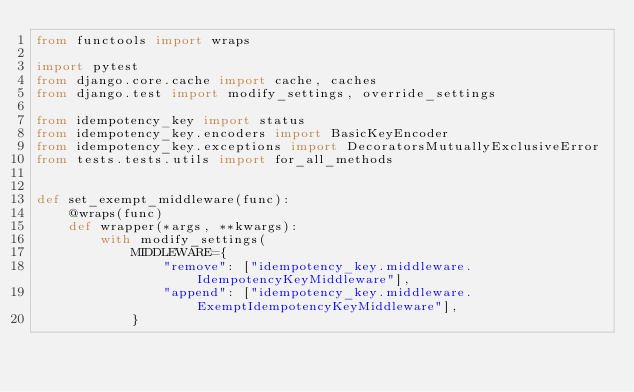Convert code to text. <code><loc_0><loc_0><loc_500><loc_500><_Python_>from functools import wraps

import pytest
from django.core.cache import cache, caches
from django.test import modify_settings, override_settings

from idempotency_key import status
from idempotency_key.encoders import BasicKeyEncoder
from idempotency_key.exceptions import DecoratorsMutuallyExclusiveError
from tests.tests.utils import for_all_methods


def set_exempt_middleware(func):
    @wraps(func)
    def wrapper(*args, **kwargs):
        with modify_settings(
            MIDDLEWARE={
                "remove": ["idempotency_key.middleware.IdempotencyKeyMiddleware"],
                "append": ["idempotency_key.middleware.ExemptIdempotencyKeyMiddleware"],
            }</code> 